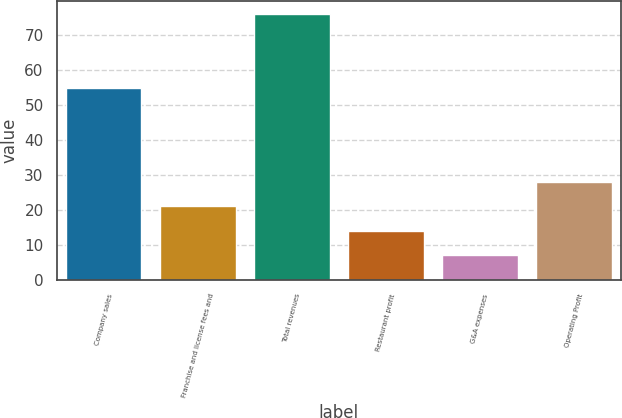Convert chart. <chart><loc_0><loc_0><loc_500><loc_500><bar_chart><fcel>Company sales<fcel>Franchise and license fees and<fcel>Total revenues<fcel>Restaurant profit<fcel>G&A expenses<fcel>Operating Profit<nl><fcel>55<fcel>21<fcel>76<fcel>14<fcel>7<fcel>28<nl></chart> 